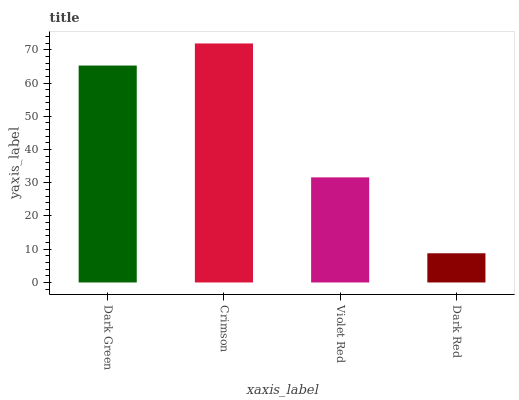Is Dark Red the minimum?
Answer yes or no. Yes. Is Crimson the maximum?
Answer yes or no. Yes. Is Violet Red the minimum?
Answer yes or no. No. Is Violet Red the maximum?
Answer yes or no. No. Is Crimson greater than Violet Red?
Answer yes or no. Yes. Is Violet Red less than Crimson?
Answer yes or no. Yes. Is Violet Red greater than Crimson?
Answer yes or no. No. Is Crimson less than Violet Red?
Answer yes or no. No. Is Dark Green the high median?
Answer yes or no. Yes. Is Violet Red the low median?
Answer yes or no. Yes. Is Dark Red the high median?
Answer yes or no. No. Is Dark Red the low median?
Answer yes or no. No. 